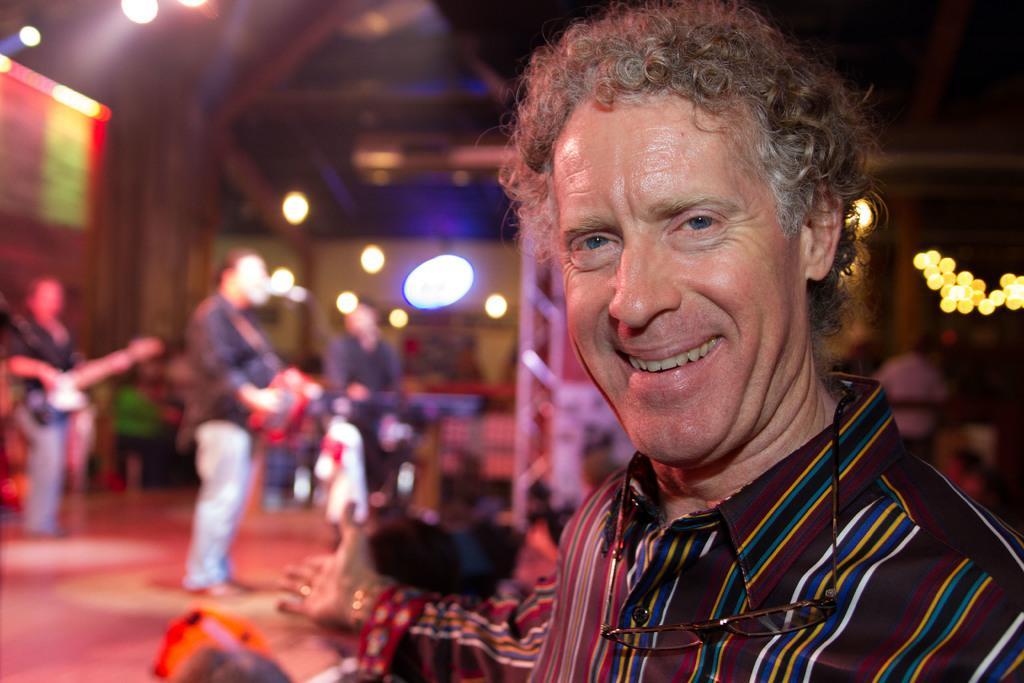Could you give a brief overview of what you see in this image? on the right side of this image I can see a man smiling and giving pose for the picture. In the background, I can see few people are playing musical instruments on the stage and also I can see some lights. 